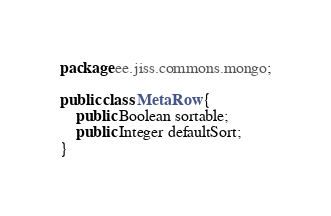<code> <loc_0><loc_0><loc_500><loc_500><_Java_>package ee.jiss.commons.mongo;

public class MetaRow {
    public Boolean sortable;
    public Integer defaultSort;
}
</code> 